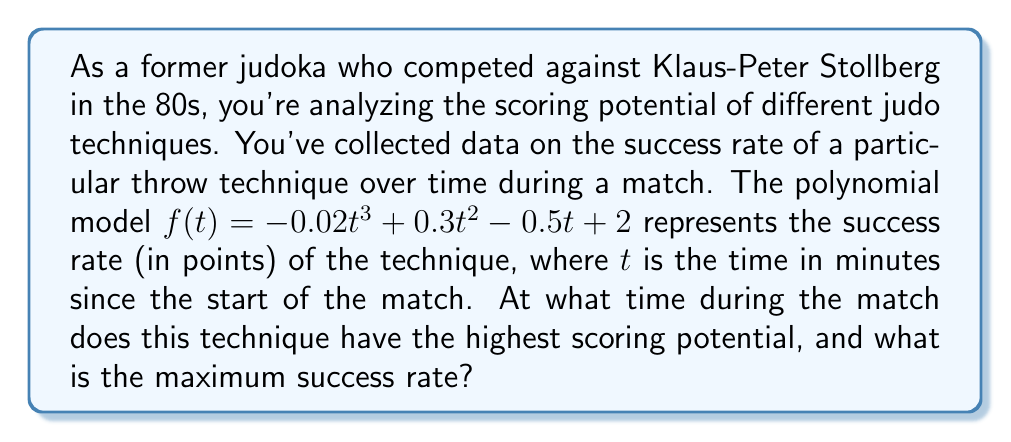Solve this math problem. To find the time when the technique has the highest scoring potential and its maximum success rate, we need to follow these steps:

1) The function $f(t) = -0.02t^3 + 0.3t^2 - 0.5t + 2$ represents the success rate over time.

2) To find the maximum, we need to find where the derivative $f'(t)$ equals zero:

   $f'(t) = -0.06t^2 + 0.6t - 0.5$

3) Set $f'(t) = 0$ and solve:

   $-0.06t^2 + 0.6t - 0.5 = 0$

4) This is a quadratic equation. We can solve it using the quadratic formula:
   
   $t = \frac{-b \pm \sqrt{b^2 - 4ac}}{2a}$

   Where $a = -0.06$, $b = 0.6$, and $c = -0.5$

5) Plugging in these values:

   $t = \frac{-0.6 \pm \sqrt{0.6^2 - 4(-0.06)(-0.5)}}{2(-0.06)}$

6) Simplifying:

   $t = \frac{-0.6 \pm \sqrt{0.36 - 0.12}}{-0.12} = \frac{-0.6 \pm \sqrt{0.24}}{-0.12} = \frac{-0.6 \pm 0.49}{-0.12}$

7) This gives us two solutions:

   $t_1 = \frac{-0.6 + 0.49}{-0.12} \approx 0.92$ minutes
   $t_2 = \frac{-0.6 - 0.49}{-0.12} \approx 9.08$ minutes

8) To determine which of these is the maximum (not the minimum), we can check the second derivative:

   $f''(t) = -0.12t + 0.6$

   At $t = 0.92$, $f''(0.92) = 0.4896 > 0$, indicating this is the maximum.

9) The maximum success rate is found by plugging $t = 0.92$ into the original function:

   $f(0.92) = -0.02(0.92)^3 + 0.3(0.92)^2 - 0.5(0.92) + 2 \approx 2.04$ points
Answer: $0.92$ minutes; $2.04$ points 